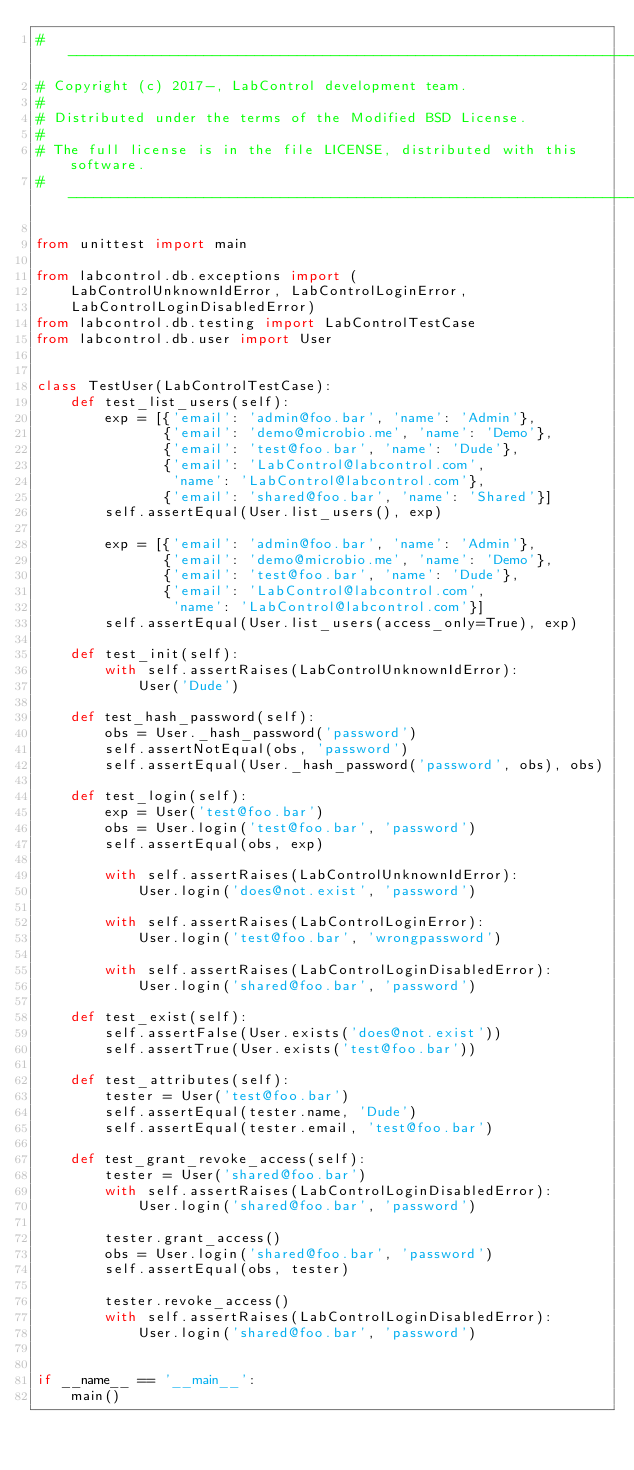<code> <loc_0><loc_0><loc_500><loc_500><_Python_># ----------------------------------------------------------------------------
# Copyright (c) 2017-, LabControl development team.
#
# Distributed under the terms of the Modified BSD License.
#
# The full license is in the file LICENSE, distributed with this software.
# ----------------------------------------------------------------------------

from unittest import main

from labcontrol.db.exceptions import (
    LabControlUnknownIdError, LabControlLoginError,
    LabControlLoginDisabledError)
from labcontrol.db.testing import LabControlTestCase
from labcontrol.db.user import User


class TestUser(LabControlTestCase):
    def test_list_users(self):
        exp = [{'email': 'admin@foo.bar', 'name': 'Admin'},
               {'email': 'demo@microbio.me', 'name': 'Demo'},
               {'email': 'test@foo.bar', 'name': 'Dude'},
               {'email': 'LabControl@labcontrol.com',
                'name': 'LabControl@labcontrol.com'},
               {'email': 'shared@foo.bar', 'name': 'Shared'}]
        self.assertEqual(User.list_users(), exp)

        exp = [{'email': 'admin@foo.bar', 'name': 'Admin'},
               {'email': 'demo@microbio.me', 'name': 'Demo'},
               {'email': 'test@foo.bar', 'name': 'Dude'},
               {'email': 'LabControl@labcontrol.com',
                'name': 'LabControl@labcontrol.com'}]
        self.assertEqual(User.list_users(access_only=True), exp)

    def test_init(self):
        with self.assertRaises(LabControlUnknownIdError):
            User('Dude')

    def test_hash_password(self):
        obs = User._hash_password('password')
        self.assertNotEqual(obs, 'password')
        self.assertEqual(User._hash_password('password', obs), obs)

    def test_login(self):
        exp = User('test@foo.bar')
        obs = User.login('test@foo.bar', 'password')
        self.assertEqual(obs, exp)

        with self.assertRaises(LabControlUnknownIdError):
            User.login('does@not.exist', 'password')

        with self.assertRaises(LabControlLoginError):
            User.login('test@foo.bar', 'wrongpassword')

        with self.assertRaises(LabControlLoginDisabledError):
            User.login('shared@foo.bar', 'password')

    def test_exist(self):
        self.assertFalse(User.exists('does@not.exist'))
        self.assertTrue(User.exists('test@foo.bar'))

    def test_attributes(self):
        tester = User('test@foo.bar')
        self.assertEqual(tester.name, 'Dude')
        self.assertEqual(tester.email, 'test@foo.bar')

    def test_grant_revoke_access(self):
        tester = User('shared@foo.bar')
        with self.assertRaises(LabControlLoginDisabledError):
            User.login('shared@foo.bar', 'password')

        tester.grant_access()
        obs = User.login('shared@foo.bar', 'password')
        self.assertEqual(obs, tester)

        tester.revoke_access()
        with self.assertRaises(LabControlLoginDisabledError):
            User.login('shared@foo.bar', 'password')


if __name__ == '__main__':
    main()
</code> 